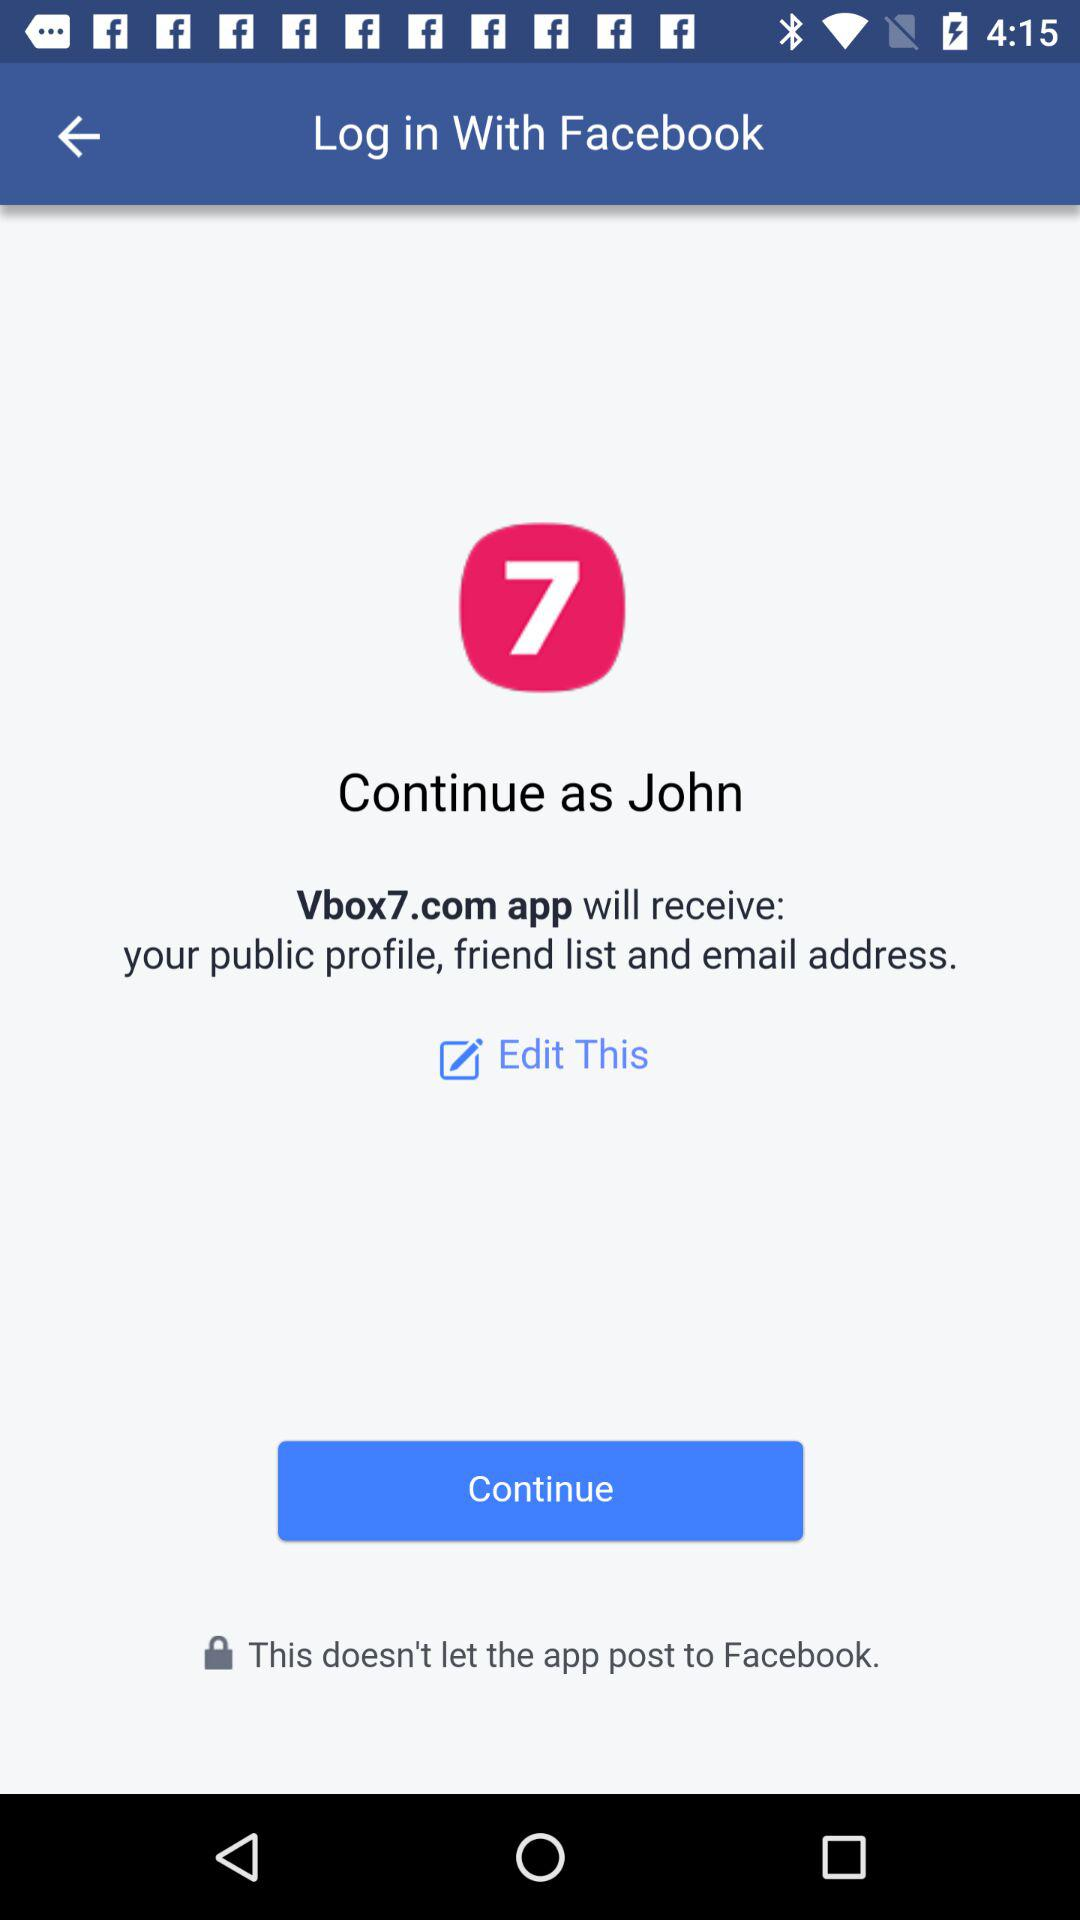What is the user name? The user name is John. 